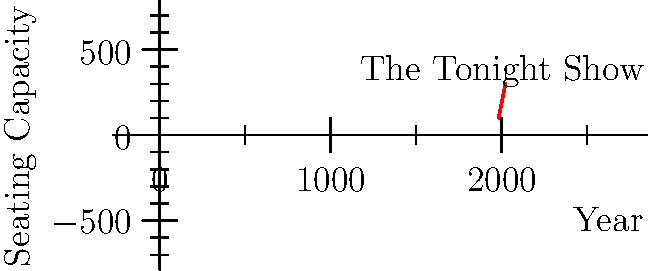Based on the graph showing the seating capacity evolution of "The Tonight Show" studio over the years, what was the approximate seating capacity in 1997? To determine the approximate seating capacity in 1997, we need to follow these steps:

1. Identify the data points closest to 1997:
   - 1992: 150 seats
   - 2002: 200 seats

2. Calculate the time difference between these points:
   $2002 - 1992 = 10$ years

3. Calculate the seating capacity difference:
   $200 - 150 = 50$ seats

4. Determine the rate of change:
   $50 \text{ seats} \div 10 \text{ years} = 5 \text{ seats per year}$

5. Calculate the time difference between 1992 and 1997:
   $1997 - 1992 = 5$ years

6. Calculate the seating capacity increase from 1992 to 1997:
   $5 \text{ years} \times 5 \text{ seats per year} = 25 \text{ seats}$

7. Add this increase to the 1992 seating capacity:
   $150 \text{ seats} + 25 \text{ seats} = 175 \text{ seats}$

Therefore, the approximate seating capacity of "The Tonight Show" studio in 1997 was 175 seats.
Answer: 175 seats 